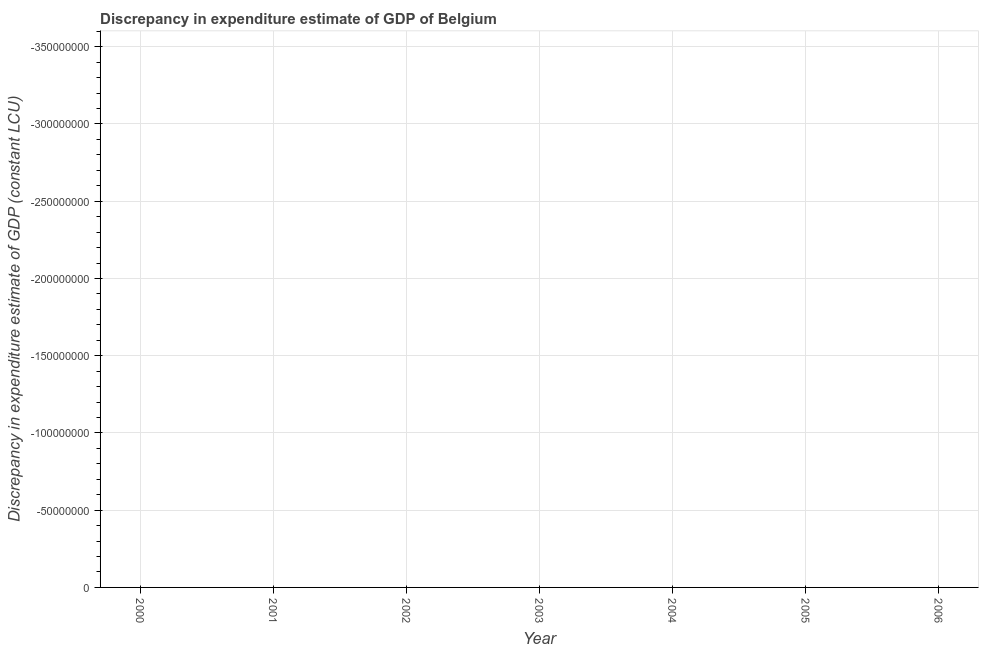Across all years, what is the minimum discrepancy in expenditure estimate of gdp?
Give a very brief answer. 0. What is the sum of the discrepancy in expenditure estimate of gdp?
Your answer should be very brief. 0. In how many years, is the discrepancy in expenditure estimate of gdp greater than the average discrepancy in expenditure estimate of gdp taken over all years?
Make the answer very short. 0. Does the discrepancy in expenditure estimate of gdp monotonically increase over the years?
Offer a terse response. No. Are the values on the major ticks of Y-axis written in scientific E-notation?
Your response must be concise. No. Does the graph contain any zero values?
Provide a short and direct response. Yes. What is the title of the graph?
Offer a terse response. Discrepancy in expenditure estimate of GDP of Belgium. What is the label or title of the X-axis?
Make the answer very short. Year. What is the label or title of the Y-axis?
Give a very brief answer. Discrepancy in expenditure estimate of GDP (constant LCU). What is the Discrepancy in expenditure estimate of GDP (constant LCU) in 2004?
Offer a terse response. 0. What is the Discrepancy in expenditure estimate of GDP (constant LCU) in 2006?
Offer a very short reply. 0. 